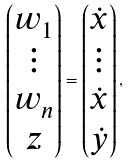Convert formula to latex. <formula><loc_0><loc_0><loc_500><loc_500>\begin{pmatrix} w _ { 1 } \\ \vdots \\ w _ { n } \\ z \end{pmatrix} = \begin{pmatrix} \dot { x } \\ \vdots \\ \dot { x } \\ \dot { y } \end{pmatrix} ,</formula> 